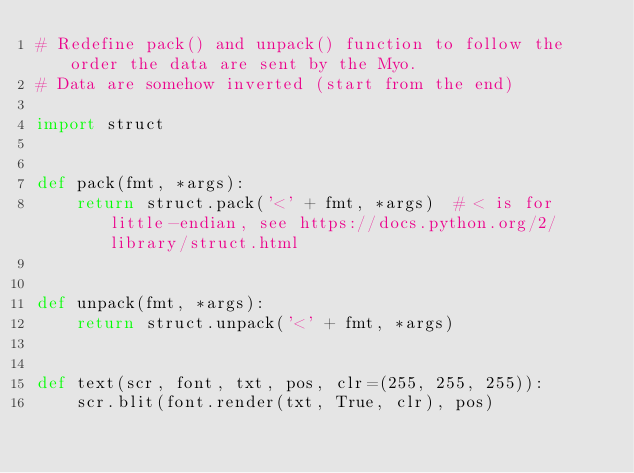<code> <loc_0><loc_0><loc_500><loc_500><_Python_># Redefine pack() and unpack() function to follow the order the data are sent by the Myo.
# Data are somehow inverted (start from the end)

import struct


def pack(fmt, *args):
    return struct.pack('<' + fmt, *args)  # < is for little-endian, see https://docs.python.org/2/library/struct.html


def unpack(fmt, *args):
    return struct.unpack('<' + fmt, *args)


def text(scr, font, txt, pos, clr=(255, 255, 255)):
    scr.blit(font.render(txt, True, clr), pos)
</code> 